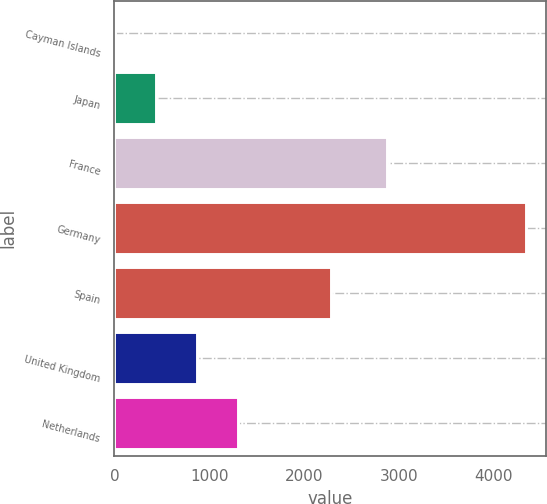<chart> <loc_0><loc_0><loc_500><loc_500><bar_chart><fcel>Cayman Islands<fcel>Japan<fcel>France<fcel>Germany<fcel>Spain<fcel>United Kingdom<fcel>Netherlands<nl><fcel>1<fcel>434.5<fcel>2871<fcel>4336<fcel>2281<fcel>868<fcel>1301.5<nl></chart> 